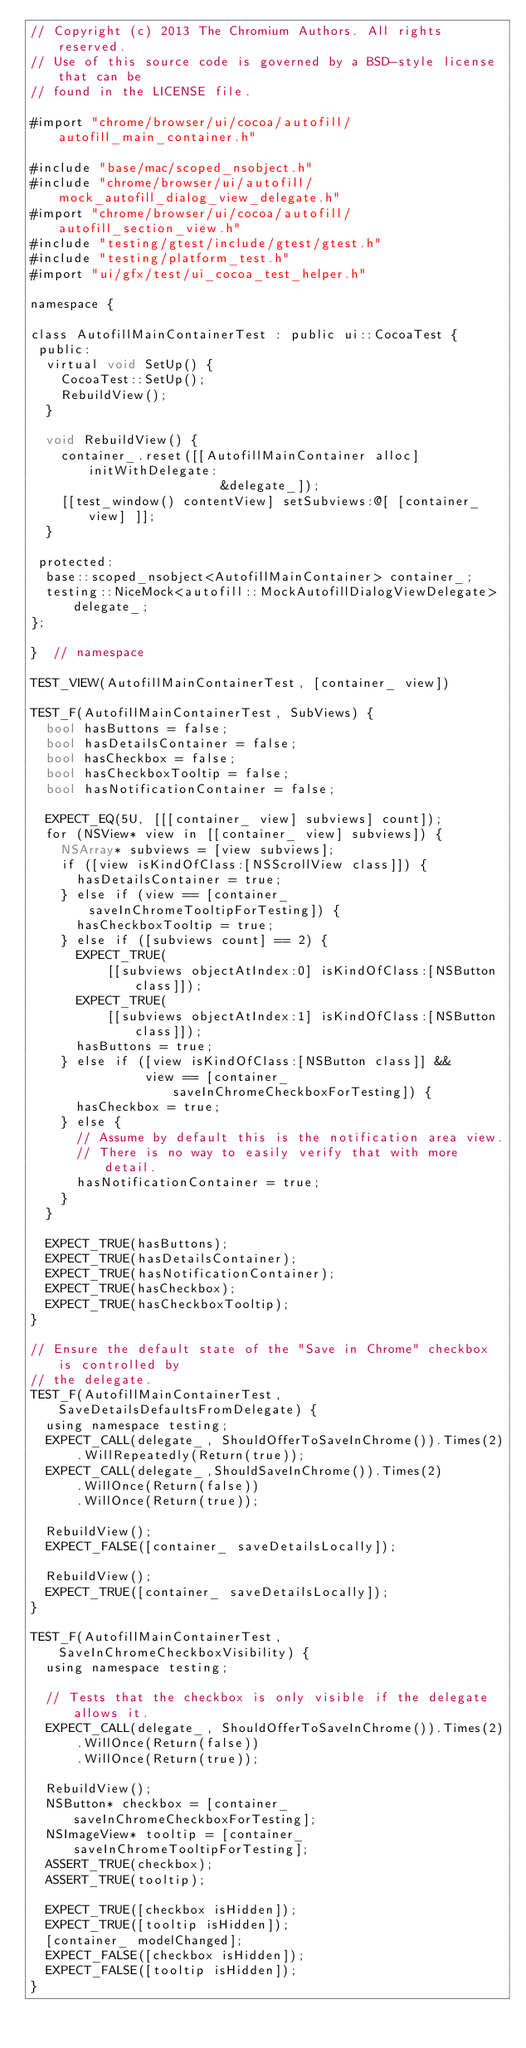Convert code to text. <code><loc_0><loc_0><loc_500><loc_500><_ObjectiveC_>// Copyright (c) 2013 The Chromium Authors. All rights reserved.
// Use of this source code is governed by a BSD-style license that can be
// found in the LICENSE file.

#import "chrome/browser/ui/cocoa/autofill/autofill_main_container.h"

#include "base/mac/scoped_nsobject.h"
#include "chrome/browser/ui/autofill/mock_autofill_dialog_view_delegate.h"
#import "chrome/browser/ui/cocoa/autofill/autofill_section_view.h"
#include "testing/gtest/include/gtest/gtest.h"
#include "testing/platform_test.h"
#import "ui/gfx/test/ui_cocoa_test_helper.h"

namespace {

class AutofillMainContainerTest : public ui::CocoaTest {
 public:
  virtual void SetUp() {
    CocoaTest::SetUp();
    RebuildView();
  }

  void RebuildView() {
    container_.reset([[AutofillMainContainer alloc] initWithDelegate:
                         &delegate_]);
    [[test_window() contentView] setSubviews:@[ [container_ view] ]];
  }

 protected:
  base::scoped_nsobject<AutofillMainContainer> container_;
  testing::NiceMock<autofill::MockAutofillDialogViewDelegate> delegate_;
};

}  // namespace

TEST_VIEW(AutofillMainContainerTest, [container_ view])

TEST_F(AutofillMainContainerTest, SubViews) {
  bool hasButtons = false;
  bool hasDetailsContainer = false;
  bool hasCheckbox = false;
  bool hasCheckboxTooltip = false;
  bool hasNotificationContainer = false;

  EXPECT_EQ(5U, [[[container_ view] subviews] count]);
  for (NSView* view in [[container_ view] subviews]) {
    NSArray* subviews = [view subviews];
    if ([view isKindOfClass:[NSScrollView class]]) {
      hasDetailsContainer = true;
    } else if (view == [container_ saveInChromeTooltipForTesting]) {
      hasCheckboxTooltip = true;
    } else if ([subviews count] == 2) {
      EXPECT_TRUE(
          [[subviews objectAtIndex:0] isKindOfClass:[NSButton class]]);
      EXPECT_TRUE(
          [[subviews objectAtIndex:1] isKindOfClass:[NSButton class]]);
      hasButtons = true;
    } else if ([view isKindOfClass:[NSButton class]] &&
               view == [container_ saveInChromeCheckboxForTesting]) {
      hasCheckbox = true;
    } else {
      // Assume by default this is the notification area view.
      // There is no way to easily verify that with more detail.
      hasNotificationContainer = true;
    }
  }

  EXPECT_TRUE(hasButtons);
  EXPECT_TRUE(hasDetailsContainer);
  EXPECT_TRUE(hasNotificationContainer);
  EXPECT_TRUE(hasCheckbox);
  EXPECT_TRUE(hasCheckboxTooltip);
}

// Ensure the default state of the "Save in Chrome" checkbox is controlled by
// the delegate.
TEST_F(AutofillMainContainerTest, SaveDetailsDefaultsFromDelegate) {
  using namespace testing;
  EXPECT_CALL(delegate_, ShouldOfferToSaveInChrome()).Times(2)
      .WillRepeatedly(Return(true));
  EXPECT_CALL(delegate_,ShouldSaveInChrome()).Times(2)
      .WillOnce(Return(false))
      .WillOnce(Return(true));

  RebuildView();
  EXPECT_FALSE([container_ saveDetailsLocally]);

  RebuildView();
  EXPECT_TRUE([container_ saveDetailsLocally]);
}

TEST_F(AutofillMainContainerTest, SaveInChromeCheckboxVisibility) {
  using namespace testing;

  // Tests that the checkbox is only visible if the delegate allows it.
  EXPECT_CALL(delegate_, ShouldOfferToSaveInChrome()).Times(2)
      .WillOnce(Return(false))
      .WillOnce(Return(true));

  RebuildView();
  NSButton* checkbox = [container_ saveInChromeCheckboxForTesting];
  NSImageView* tooltip = [container_ saveInChromeTooltipForTesting];
  ASSERT_TRUE(checkbox);
  ASSERT_TRUE(tooltip);

  EXPECT_TRUE([checkbox isHidden]);
  EXPECT_TRUE([tooltip isHidden]);
  [container_ modelChanged];
  EXPECT_FALSE([checkbox isHidden]);
  EXPECT_FALSE([tooltip isHidden]);
}
</code> 